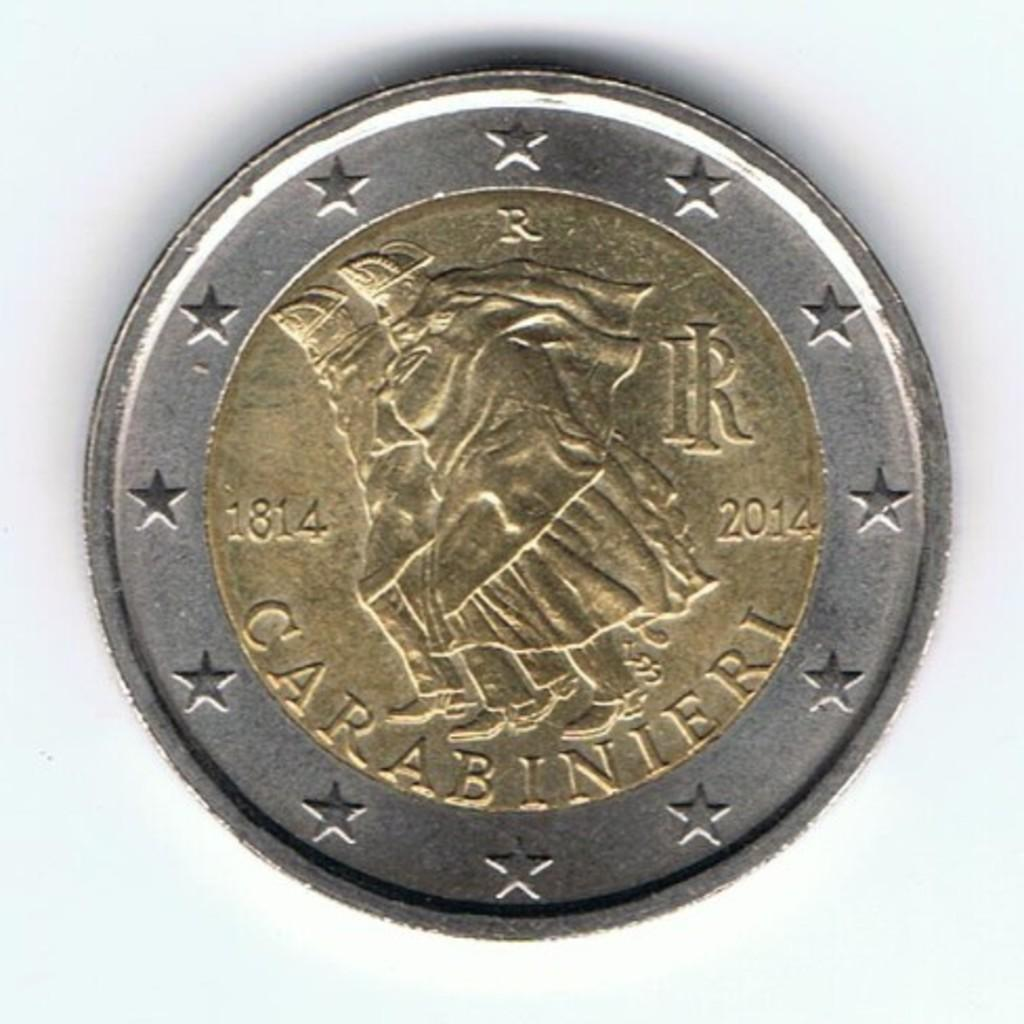<image>
Share a concise interpretation of the image provided. a coin with the years 1814 and 2014 on it and labeled 'carabinieri' 